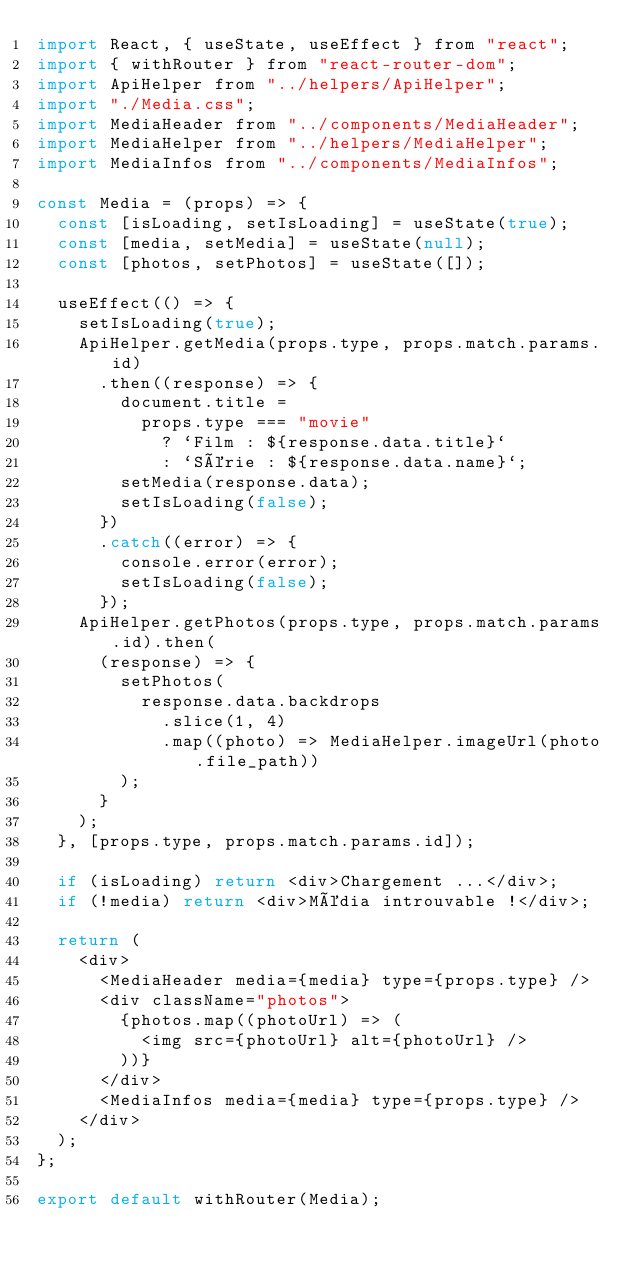Convert code to text. <code><loc_0><loc_0><loc_500><loc_500><_JavaScript_>import React, { useState, useEffect } from "react";
import { withRouter } from "react-router-dom";
import ApiHelper from "../helpers/ApiHelper";
import "./Media.css";
import MediaHeader from "../components/MediaHeader";
import MediaHelper from "../helpers/MediaHelper";
import MediaInfos from "../components/MediaInfos";

const Media = (props) => {
  const [isLoading, setIsLoading] = useState(true);
  const [media, setMedia] = useState(null);
  const [photos, setPhotos] = useState([]);

  useEffect(() => {
    setIsLoading(true);
    ApiHelper.getMedia(props.type, props.match.params.id)
      .then((response) => {
        document.title =
          props.type === "movie"
            ? `Film : ${response.data.title}`
            : `Série : ${response.data.name}`;
        setMedia(response.data);
        setIsLoading(false);
      })
      .catch((error) => {
        console.error(error);
        setIsLoading(false);
      });
    ApiHelper.getPhotos(props.type, props.match.params.id).then(
      (response) => {
        setPhotos(
          response.data.backdrops
            .slice(1, 4)
            .map((photo) => MediaHelper.imageUrl(photo.file_path))
        );
      }
    );
  }, [props.type, props.match.params.id]);

  if (isLoading) return <div>Chargement ...</div>;
  if (!media) return <div>Média introuvable !</div>;

  return (
    <div>
      <MediaHeader media={media} type={props.type} />
      <div className="photos">
        {photos.map((photoUrl) => (
          <img src={photoUrl} alt={photoUrl} />
        ))}
      </div>
      <MediaInfos media={media} type={props.type} />
    </div>
  );
};

export default withRouter(Media);
</code> 